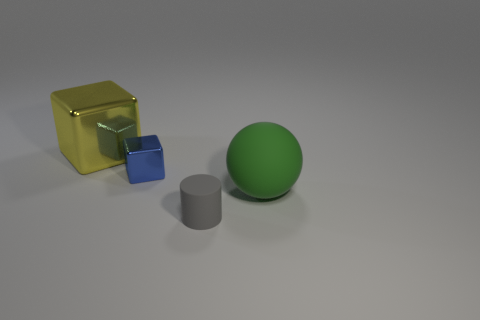The tiny object that is in front of the big thing that is in front of the block that is right of the large yellow shiny object is what shape?
Your answer should be very brief. Cylinder. Are there an equal number of blue blocks that are behind the green rubber object and small blue metallic blocks that are in front of the small gray matte cylinder?
Provide a short and direct response. No. There is a object that is the same size as the cylinder; what is its color?
Give a very brief answer. Blue. How many tiny things are either purple rubber cubes or blue blocks?
Provide a short and direct response. 1. The object that is both in front of the blue metallic thing and behind the small gray matte thing is made of what material?
Offer a very short reply. Rubber. There is a big shiny thing that is behind the tiny blue shiny block; is its shape the same as the matte object behind the cylinder?
Give a very brief answer. No. How many objects are either big things that are behind the ball or small purple rubber cubes?
Provide a succinct answer. 1. Does the blue shiny cube have the same size as the yellow metal thing?
Make the answer very short. No. There is a matte thing behind the tiny gray matte cylinder; what is its color?
Make the answer very short. Green. There is a green sphere that is made of the same material as the small gray object; what is its size?
Your answer should be very brief. Large. 